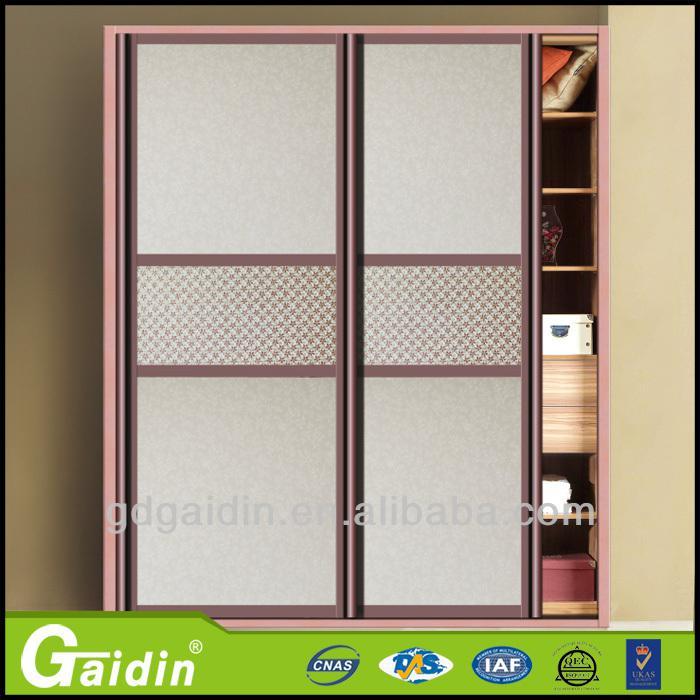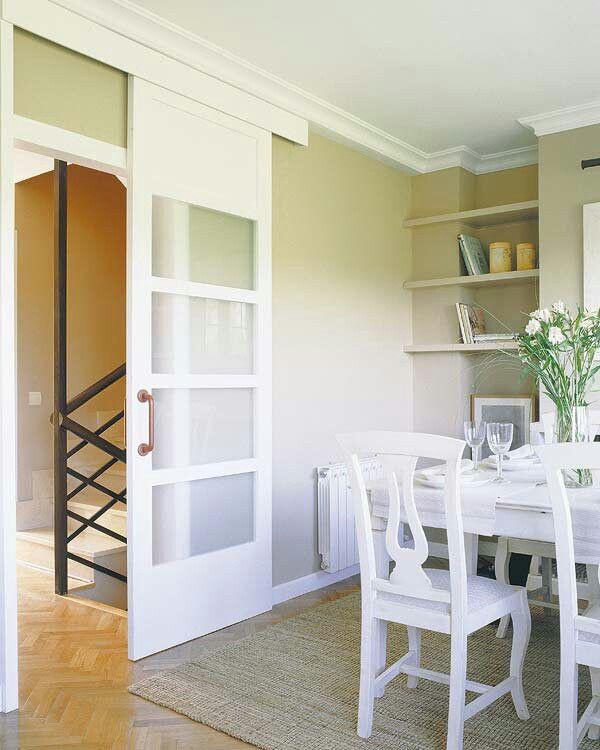The first image is the image on the left, the second image is the image on the right. Considering the images on both sides, is "In one image, at least one door panel with white frame and glass inserts is shown in an open position." valid? Answer yes or no. Yes. The first image is the image on the left, the second image is the image on the right. For the images shown, is this caption "Chairs sit near a table in a home." true? Answer yes or no. Yes. 